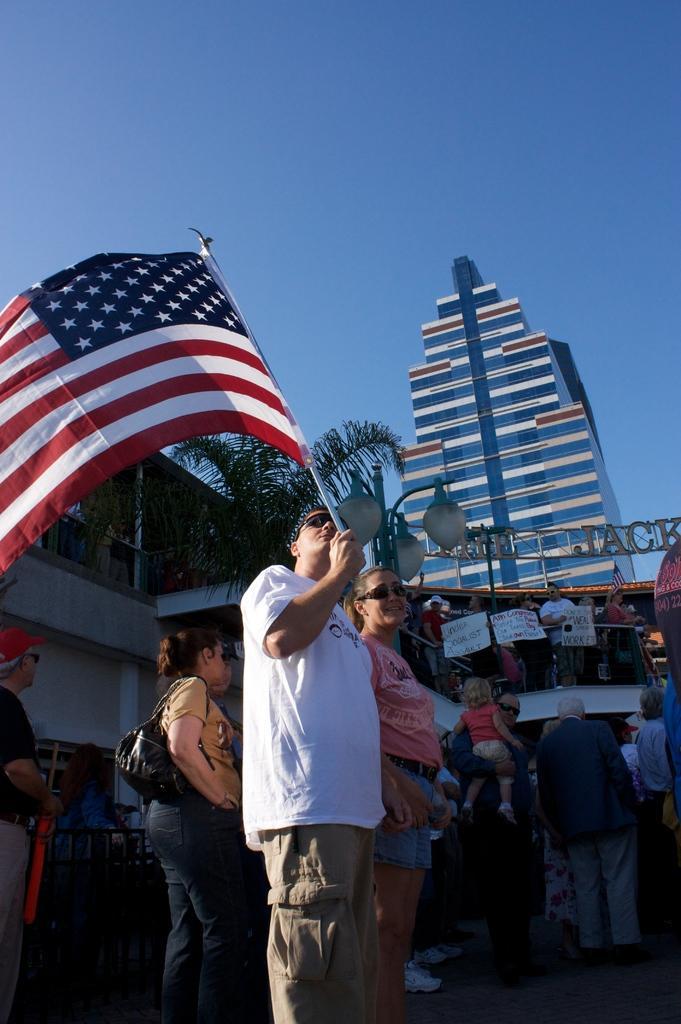How would you summarize this image in a sentence or two? In the image there is a man in white t-shirt standing in the front holding a flag and behind there are many people standing all over the place and in the background there is a skyscraper and above its sky. 